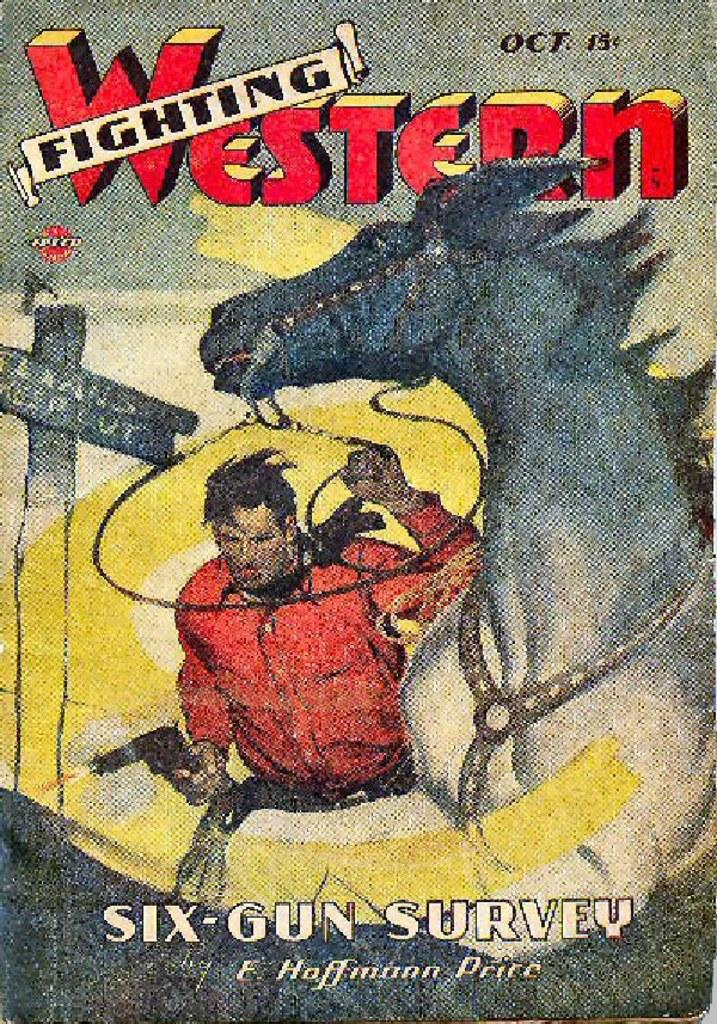<image>
Provide a brief description of the given image. A cover for a Fighting Western comic with a cowboy and horse on it. 